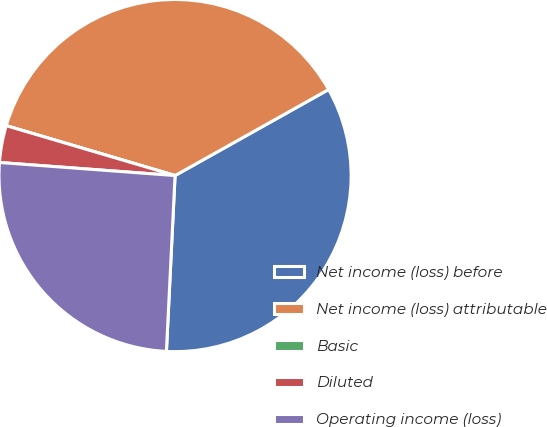<chart> <loc_0><loc_0><loc_500><loc_500><pie_chart><fcel>Net income (loss) before<fcel>Net income (loss) attributable<fcel>Basic<fcel>Diluted<fcel>Operating income (loss)<nl><fcel>33.91%<fcel>37.3%<fcel>0.0%<fcel>3.39%<fcel>25.4%<nl></chart> 